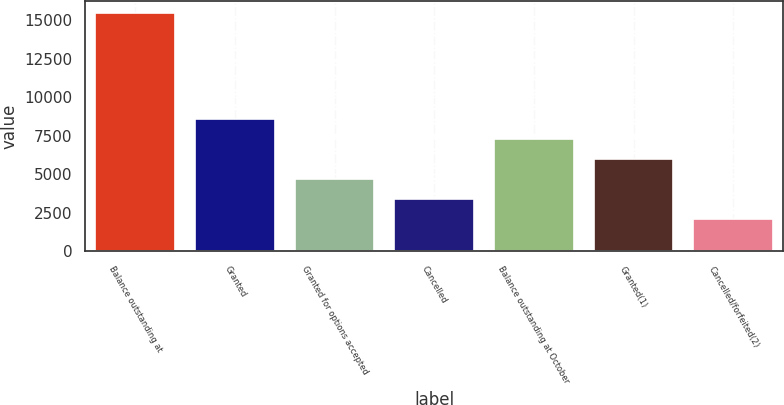Convert chart to OTSL. <chart><loc_0><loc_0><loc_500><loc_500><bar_chart><fcel>Balance outstanding at<fcel>Granted<fcel>Granted for options accepted<fcel>Cancelled<fcel>Balance outstanding at October<fcel>Granted(1)<fcel>Cancelled/forfeited(2)<nl><fcel>15484.8<fcel>8572<fcel>4696.6<fcel>3404.8<fcel>7280.2<fcel>5988.4<fcel>2113<nl></chart> 